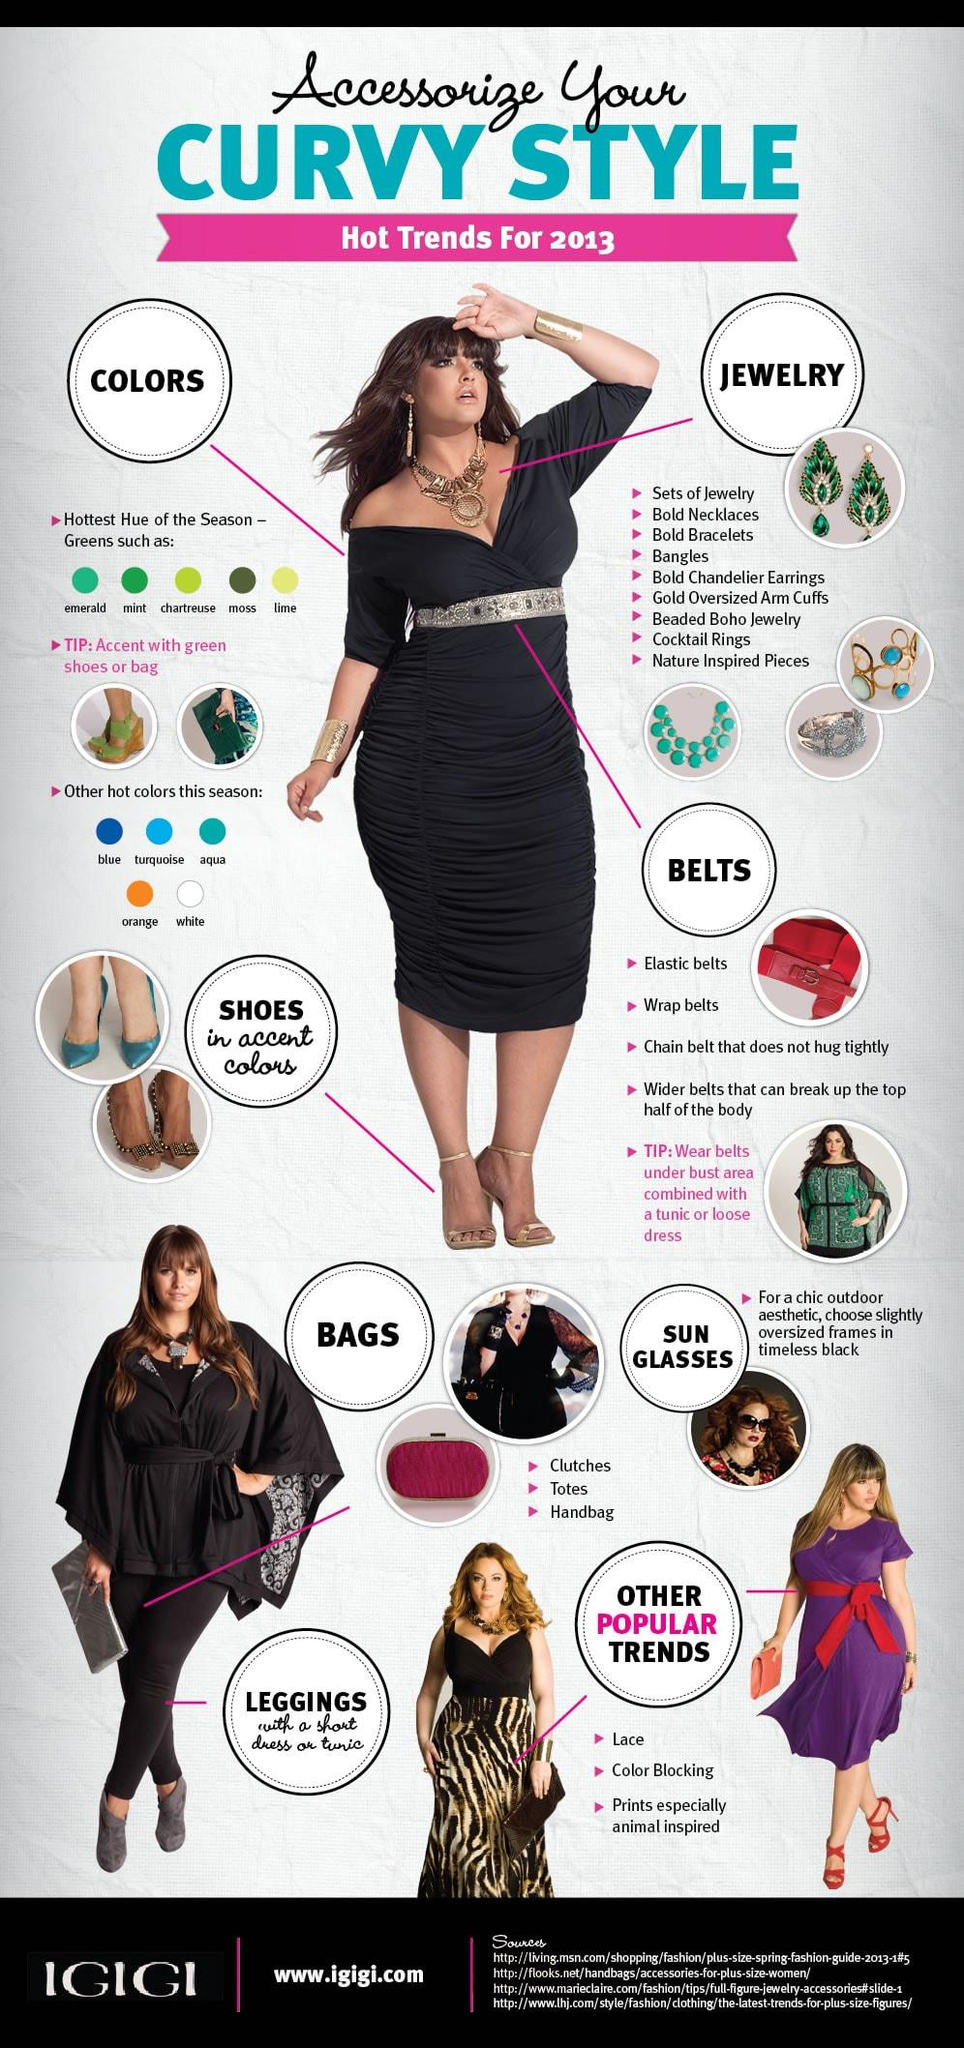Specify some key components in this picture. There are nine types of jewelry mentioned in this infographic. This infographic mentions three types of bags. The infographic mentions 5 hot colors of the season. The infographic mentions 5 shades of green color. There are four types of belts mentioned in this infographic. 